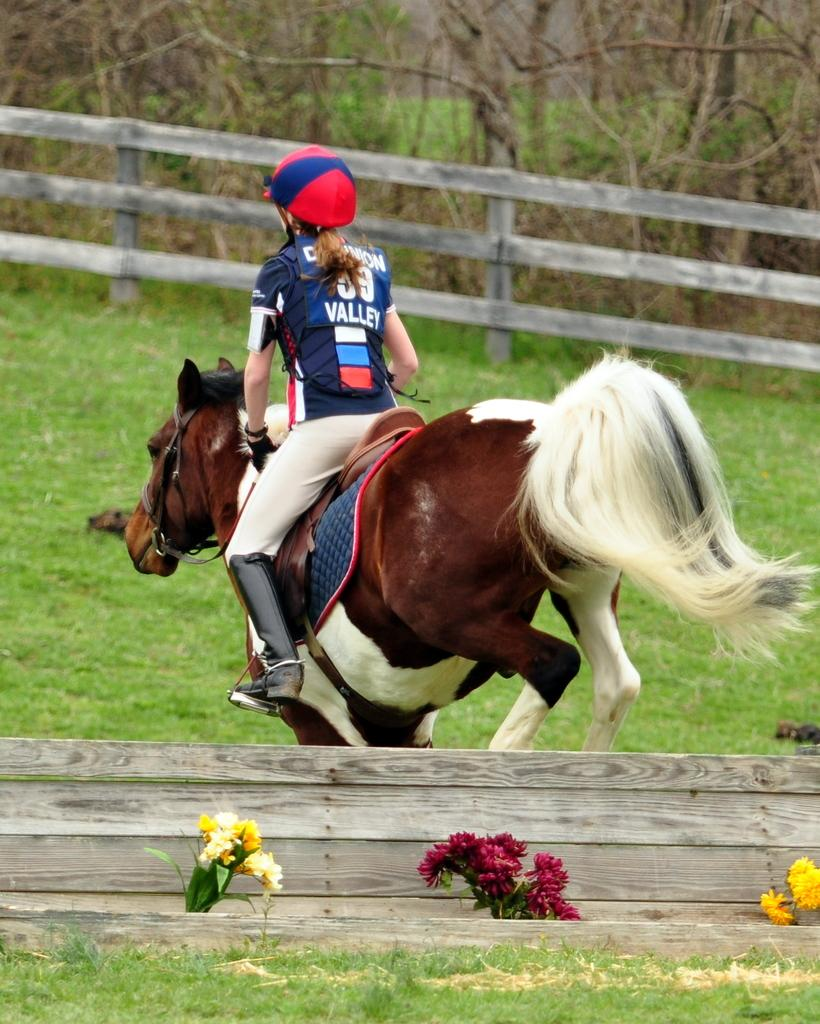What is the person in the image doing? The person is riding a horse in the image. What type of vegetation can be seen in the image? There are flowers and grass visible in the image. What is the material of the fence in the image? The fence in the image is made of wood. How many ducks are resting on the wooden fence in the image? There are no ducks present in the image, so it is not possible to answer that question. 